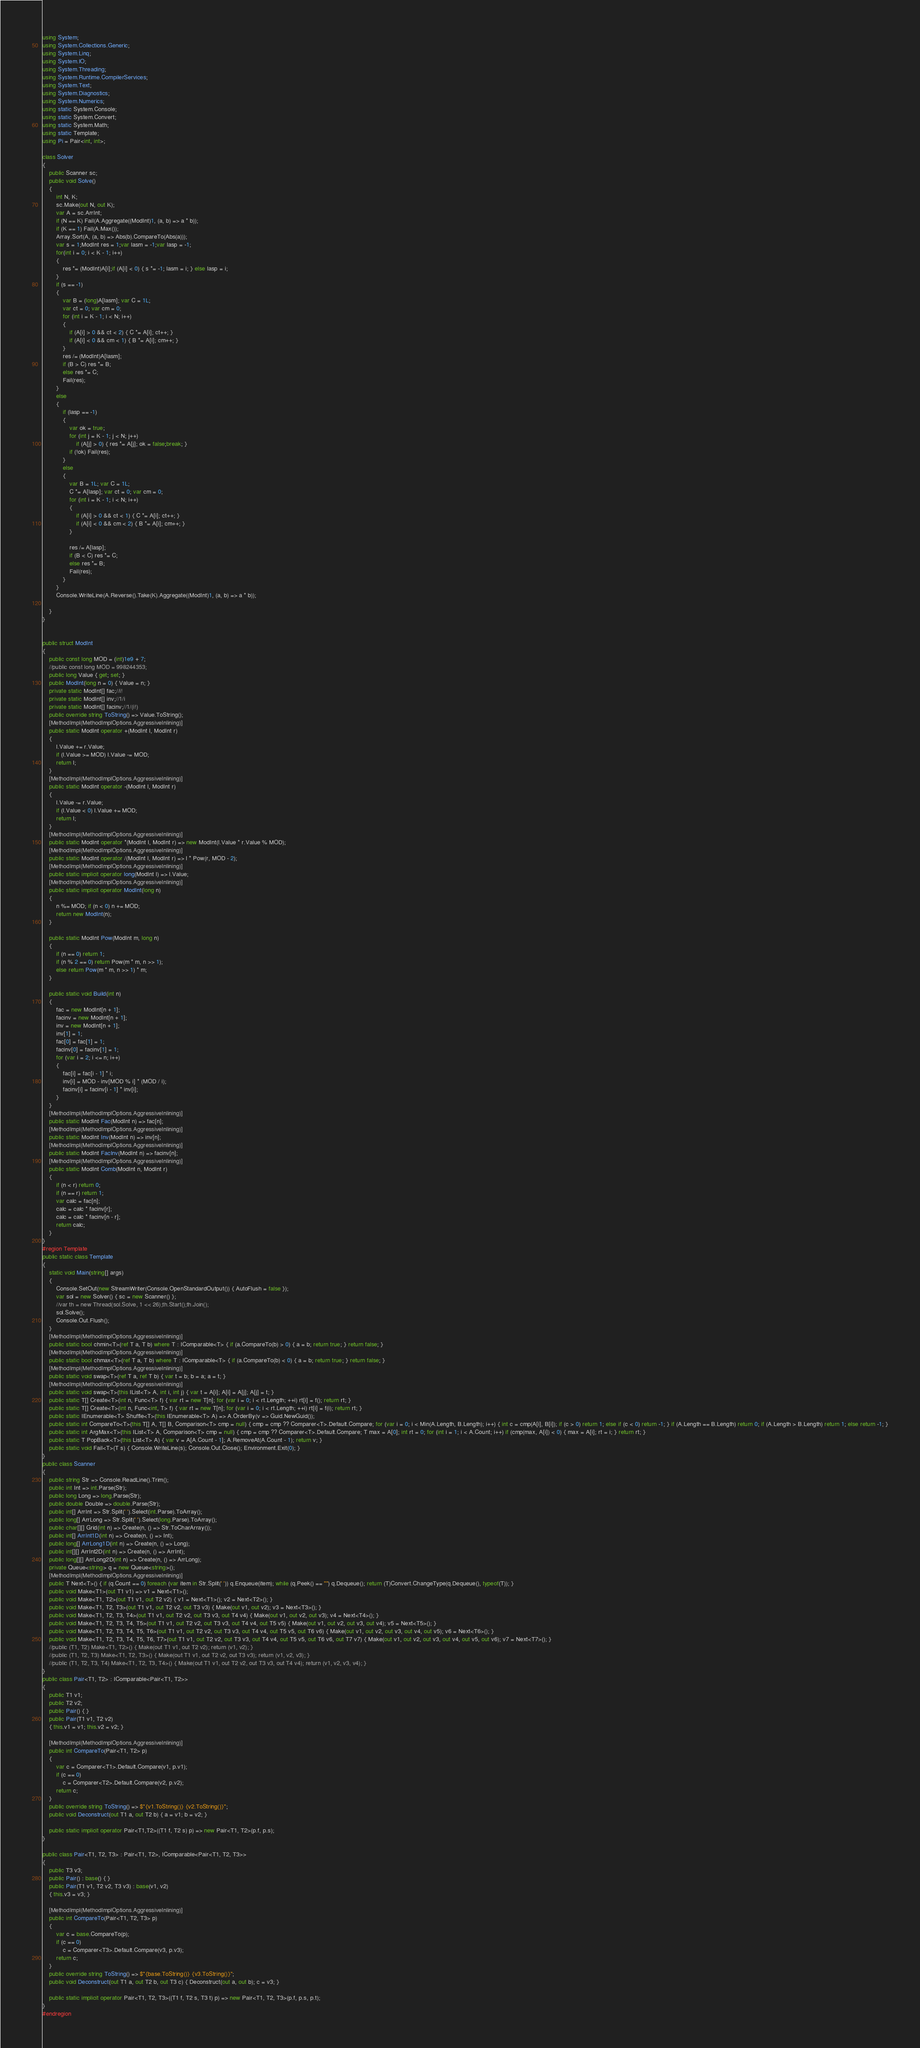<code> <loc_0><loc_0><loc_500><loc_500><_C#_>using System;
using System.Collections.Generic;
using System.Linq;
using System.IO;
using System.Threading;
using System.Runtime.CompilerServices;
using System.Text;
using System.Diagnostics;
using System.Numerics;
using static System.Console;
using static System.Convert;
using static System.Math;
using static Template;
using Pi = Pair<int, int>;

class Solver
{
    public Scanner sc;
    public void Solve()
    {
        int N, K;
        sc.Make(out N, out K);
        var A = sc.ArrInt;
        if (N == K) Fail(A.Aggregate((ModInt)1, (a, b) => a * b));
        if (K == 1) Fail(A.Max());
        Array.Sort(A, (a, b) => Abs(b).CompareTo(Abs(a)));
        var s = 1;ModInt res = 1;var lasm = -1;var lasp = -1;
        for(int i = 0; i < K - 1; i++)
        {
            res *= (ModInt)A[i];if (A[i] < 0) { s *= -1; lasm = i; } else lasp = i;
        }
        if (s == -1)
        {
            var B = (long)A[lasm]; var C = 1L;
            var ct = 0; var cm = 0;
            for (int i = K - 1; i < N; i++)
            {
                if (A[i] > 0 && ct < 2) { C *= A[i]; ct++; }
                if (A[i] < 0 && cm < 1) { B *= A[i]; cm++; }
            }
            res /= (ModInt)A[lasm];
            if (B > C) res *= B;
            else res *= C;
            Fail(res);
        }
        else
        {
            if (lasp == -1)
            {
                var ok = true;
                for (int j = K - 1; j < N; j++)
                    if (A[j] > 0) { res *= A[j]; ok = false;break; }
                if (!ok) Fail(res);
            }
            else
            {
                var B = 1L; var C = 1L;
                C *= A[lasp]; var ct = 0; var cm = 0;
                for (int i = K - 1; i < N; i++)
                {
                    if (A[i] > 0 && ct < 1) { C *= A[i]; ct++; }
                    if (A[i] < 0 && cm < 2) { B *= A[i]; cm++; }
                }

                res /= A[lasp];
                if (B < C) res *= C;
                else res *= B;
                Fail(res);
            }
        }
        Console.WriteLine(A.Reverse().Take(K).Aggregate((ModInt)1, (a, b) => a * b));

    }
}


public struct ModInt
{
    public const long MOD = (int)1e9 + 7;
    //public const long MOD = 998244353;
    public long Value { get; set; }
    public ModInt(long n = 0) { Value = n; }
    private static ModInt[] fac;//i!
    private static ModInt[] inv;//1/i
    private static ModInt[] facinv;//1/(i!)
    public override string ToString() => Value.ToString();
    [MethodImpl(MethodImplOptions.AggressiveInlining)]
    public static ModInt operator +(ModInt l, ModInt r)
    {
        l.Value += r.Value;
        if (l.Value >= MOD) l.Value -= MOD;
        return l;
    }
    [MethodImpl(MethodImplOptions.AggressiveInlining)]
    public static ModInt operator -(ModInt l, ModInt r)
    {
        l.Value -= r.Value;
        if (l.Value < 0) l.Value += MOD;
        return l;
    }
    [MethodImpl(MethodImplOptions.AggressiveInlining)]
    public static ModInt operator *(ModInt l, ModInt r) => new ModInt(l.Value * r.Value % MOD);
    [MethodImpl(MethodImplOptions.AggressiveInlining)]
    public static ModInt operator /(ModInt l, ModInt r) => l * Pow(r, MOD - 2);
    [MethodImpl(MethodImplOptions.AggressiveInlining)]
    public static implicit operator long(ModInt l) => l.Value;
    [MethodImpl(MethodImplOptions.AggressiveInlining)]
    public static implicit operator ModInt(long n)
    {
        n %= MOD; if (n < 0) n += MOD;
        return new ModInt(n);
    }

    public static ModInt Pow(ModInt m, long n)
    {
        if (n == 0) return 1;
        if (n % 2 == 0) return Pow(m * m, n >> 1);
        else return Pow(m * m, n >> 1) * m;
    }

    public static void Build(int n)
    {
        fac = new ModInt[n + 1];
        facinv = new ModInt[n + 1];
        inv = new ModInt[n + 1];
        inv[1] = 1;
        fac[0] = fac[1] = 1;
        facinv[0] = facinv[1] = 1;
        for (var i = 2; i <= n; i++)
        {
            fac[i] = fac[i - 1] * i;
            inv[i] = MOD - inv[MOD % i] * (MOD / i);
            facinv[i] = facinv[i - 1] * inv[i];
        }
    }
    [MethodImpl(MethodImplOptions.AggressiveInlining)]
    public static ModInt Fac(ModInt n) => fac[n];
    [MethodImpl(MethodImplOptions.AggressiveInlining)]
    public static ModInt Inv(ModInt n) => inv[n];
    [MethodImpl(MethodImplOptions.AggressiveInlining)]
    public static ModInt FacInv(ModInt n) => facinv[n];
    [MethodImpl(MethodImplOptions.AggressiveInlining)]
    public static ModInt Comb(ModInt n, ModInt r)
    {
        if (n < r) return 0;
        if (n == r) return 1;
        var calc = fac[n];
        calc = calc * facinv[r];
        calc = calc * facinv[n - r];
        return calc;
    }
}
#region Template
public static class Template
{
    static void Main(string[] args)
    {
        Console.SetOut(new StreamWriter(Console.OpenStandardOutput()) { AutoFlush = false });
        var sol = new Solver() { sc = new Scanner() };
        //var th = new Thread(sol.Solve, 1 << 26);th.Start();th.Join();
        sol.Solve();
        Console.Out.Flush();
    }
    [MethodImpl(MethodImplOptions.AggressiveInlining)]
    public static bool chmin<T>(ref T a, T b) where T : IComparable<T> { if (a.CompareTo(b) > 0) { a = b; return true; } return false; }
    [MethodImpl(MethodImplOptions.AggressiveInlining)]
    public static bool chmax<T>(ref T a, T b) where T : IComparable<T> { if (a.CompareTo(b) < 0) { a = b; return true; } return false; }
    [MethodImpl(MethodImplOptions.AggressiveInlining)]
    public static void swap<T>(ref T a, ref T b) { var t = b; b = a; a = t; }
    [MethodImpl(MethodImplOptions.AggressiveInlining)]
    public static void swap<T>(this IList<T> A, int i, int j) { var t = A[i]; A[i] = A[j]; A[j] = t; }
    public static T[] Create<T>(int n, Func<T> f) { var rt = new T[n]; for (var i = 0; i < rt.Length; ++i) rt[i] = f(); return rt; }
    public static T[] Create<T>(int n, Func<int, T> f) { var rt = new T[n]; for (var i = 0; i < rt.Length; ++i) rt[i] = f(i); return rt; }
    public static IEnumerable<T> Shuffle<T>(this IEnumerable<T> A) => A.OrderBy(v => Guid.NewGuid());
    public static int CompareTo<T>(this T[] A, T[] B, Comparison<T> cmp = null) { cmp = cmp ?? Comparer<T>.Default.Compare; for (var i = 0; i < Min(A.Length, B.Length); i++) { int c = cmp(A[i], B[i]); if (c > 0) return 1; else if (c < 0) return -1; } if (A.Length == B.Length) return 0; if (A.Length > B.Length) return 1; else return -1; }
    public static int ArgMax<T>(this IList<T> A, Comparison<T> cmp = null) { cmp = cmp ?? Comparer<T>.Default.Compare; T max = A[0]; int rt = 0; for (int i = 1; i < A.Count; i++) if (cmp(max, A[i]) < 0) { max = A[i]; rt = i; } return rt; }
    public static T PopBack<T>(this List<T> A) { var v = A[A.Count - 1]; A.RemoveAt(A.Count - 1); return v; }
    public static void Fail<T>(T s) { Console.WriteLine(s); Console.Out.Close(); Environment.Exit(0); }
}
public class Scanner
{
    public string Str => Console.ReadLine().Trim();
    public int Int => int.Parse(Str);
    public long Long => long.Parse(Str);
    public double Double => double.Parse(Str);
    public int[] ArrInt => Str.Split(' ').Select(int.Parse).ToArray();
    public long[] ArrLong => Str.Split(' ').Select(long.Parse).ToArray();
    public char[][] Grid(int n) => Create(n, () => Str.ToCharArray());
    public int[] ArrInt1D(int n) => Create(n, () => Int);
    public long[] ArrLong1D(int n) => Create(n, () => Long);
    public int[][] ArrInt2D(int n) => Create(n, () => ArrInt);
    public long[][] ArrLong2D(int n) => Create(n, () => ArrLong);
    private Queue<string> q = new Queue<string>();
    [MethodImpl(MethodImplOptions.AggressiveInlining)]
    public T Next<T>() { if (q.Count == 0) foreach (var item in Str.Split(' ')) q.Enqueue(item); while (q.Peek() == "") q.Dequeue(); return (T)Convert.ChangeType(q.Dequeue(), typeof(T)); }
    public void Make<T1>(out T1 v1) => v1 = Next<T1>();
    public void Make<T1, T2>(out T1 v1, out T2 v2) { v1 = Next<T1>(); v2 = Next<T2>(); }
    public void Make<T1, T2, T3>(out T1 v1, out T2 v2, out T3 v3) { Make(out v1, out v2); v3 = Next<T3>(); }
    public void Make<T1, T2, T3, T4>(out T1 v1, out T2 v2, out T3 v3, out T4 v4) { Make(out v1, out v2, out v3); v4 = Next<T4>(); }
    public void Make<T1, T2, T3, T4, T5>(out T1 v1, out T2 v2, out T3 v3, out T4 v4, out T5 v5) { Make(out v1, out v2, out v3, out v4); v5 = Next<T5>(); }
    public void Make<T1, T2, T3, T4, T5, T6>(out T1 v1, out T2 v2, out T3 v3, out T4 v4, out T5 v5, out T6 v6) { Make(out v1, out v2, out v3, out v4, out v5); v6 = Next<T6>(); }
    public void Make<T1, T2, T3, T4, T5, T6, T7>(out T1 v1, out T2 v2, out T3 v3, out T4 v4, out T5 v5, out T6 v6, out T7 v7) { Make(out v1, out v2, out v3, out v4, out v5, out v6); v7 = Next<T7>(); }
    //public (T1, T2) Make<T1, T2>() { Make(out T1 v1, out T2 v2); return (v1, v2); }
    //public (T1, T2, T3) Make<T1, T2, T3>() { Make(out T1 v1, out T2 v2, out T3 v3); return (v1, v2, v3); }
    //public (T1, T2, T3, T4) Make<T1, T2, T3, T4>() { Make(out T1 v1, out T2 v2, out T3 v3, out T4 v4); return (v1, v2, v3, v4); }
}
public class Pair<T1, T2> : IComparable<Pair<T1, T2>>
{
    public T1 v1;
    public T2 v2;
    public Pair() { }
    public Pair(T1 v1, T2 v2)
    { this.v1 = v1; this.v2 = v2; }

    [MethodImpl(MethodImplOptions.AggressiveInlining)]
    public int CompareTo(Pair<T1, T2> p)
    {
        var c = Comparer<T1>.Default.Compare(v1, p.v1);
        if (c == 0)
            c = Comparer<T2>.Default.Compare(v2, p.v2);
        return c;
    }
    public override string ToString() => $"{v1.ToString()} {v2.ToString()}";
    public void Deconstruct(out T1 a, out T2 b) { a = v1; b = v2; }

    public static implicit operator Pair<T1,T2>((T1 f, T2 s) p) => new Pair<T1, T2>(p.f, p.s);
}

public class Pair<T1, T2, T3> : Pair<T1, T2>, IComparable<Pair<T1, T2, T3>>
{
    public T3 v3;
    public Pair() : base() { }
    public Pair(T1 v1, T2 v2, T3 v3) : base(v1, v2)
    { this.v3 = v3; }

    [MethodImpl(MethodImplOptions.AggressiveInlining)]
    public int CompareTo(Pair<T1, T2, T3> p)
    {
        var c = base.CompareTo(p);
        if (c == 0)
            c = Comparer<T3>.Default.Compare(v3, p.v3);
        return c;
    }
    public override string ToString() => $"{base.ToString()} {v3.ToString()}";
    public void Deconstruct(out T1 a, out T2 b, out T3 c) { Deconstruct(out a, out b); c = v3; }

    public static implicit operator Pair<T1, T2, T3>((T1 f, T2 s, T3 t) p) => new Pair<T1, T2, T3>(p.f, p.s, p.t);
}
#endregion
</code> 